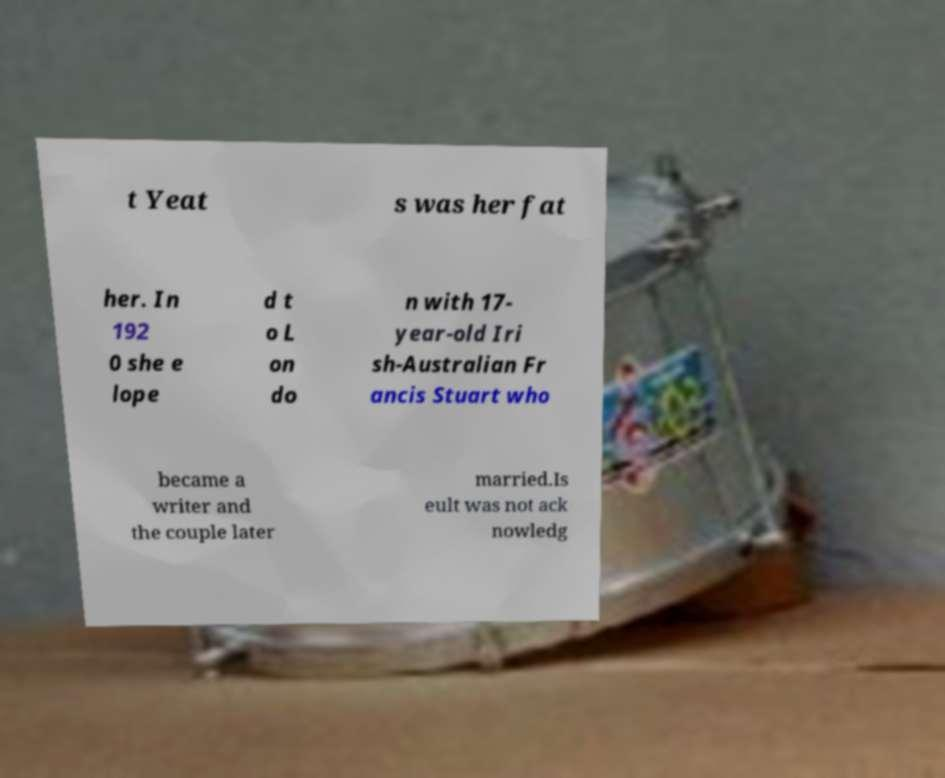Please read and relay the text visible in this image. What does it say? t Yeat s was her fat her. In 192 0 she e lope d t o L on do n with 17- year-old Iri sh-Australian Fr ancis Stuart who became a writer and the couple later married.Is eult was not ack nowledg 